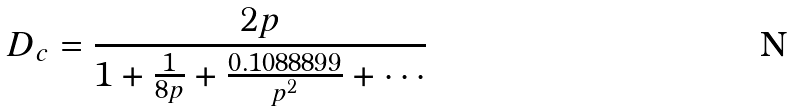Convert formula to latex. <formula><loc_0><loc_0><loc_500><loc_500>D _ { c } = \frac { 2 p } { 1 + \frac { 1 } { 8 p } + \frac { 0 . 1 0 8 8 8 9 9 } { p ^ { 2 } } + \cdots }</formula> 